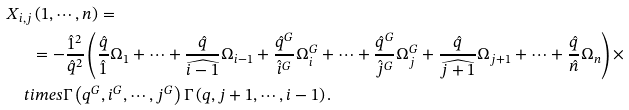<formula> <loc_0><loc_0><loc_500><loc_500>& X _ { i , j } \left ( 1 , \cdots , n \right ) = \\ & \quad \ \ = - \frac { \hat { 1 } ^ { 2 } } { \hat { q } ^ { 2 } } \left ( \frac { \hat { q } } { \hat { 1 } } \Omega _ { 1 } + \cdots + \frac { \hat { q } } { \widehat { i - 1 } } \Omega _ { i - 1 } + \frac { \hat { q } ^ { G } } { \hat { i } ^ { G } } \Omega _ { i } ^ { G } + \cdots + \frac { \hat { q } ^ { G } } { \hat { j } ^ { G } } \Omega _ { j } ^ { G } + \frac { \hat { q } } { \widehat { j + 1 } } \Omega _ { j + 1 } + \cdots + \frac { \hat { q } } { \hat { n } } \Omega _ { n } \right ) \times \\ & \quad t i m e s \Gamma \left ( q ^ { G } , i ^ { G } , \cdots , j ^ { G } \right ) \Gamma \left ( q , j + 1 , \cdots , i - 1 \right ) .</formula> 